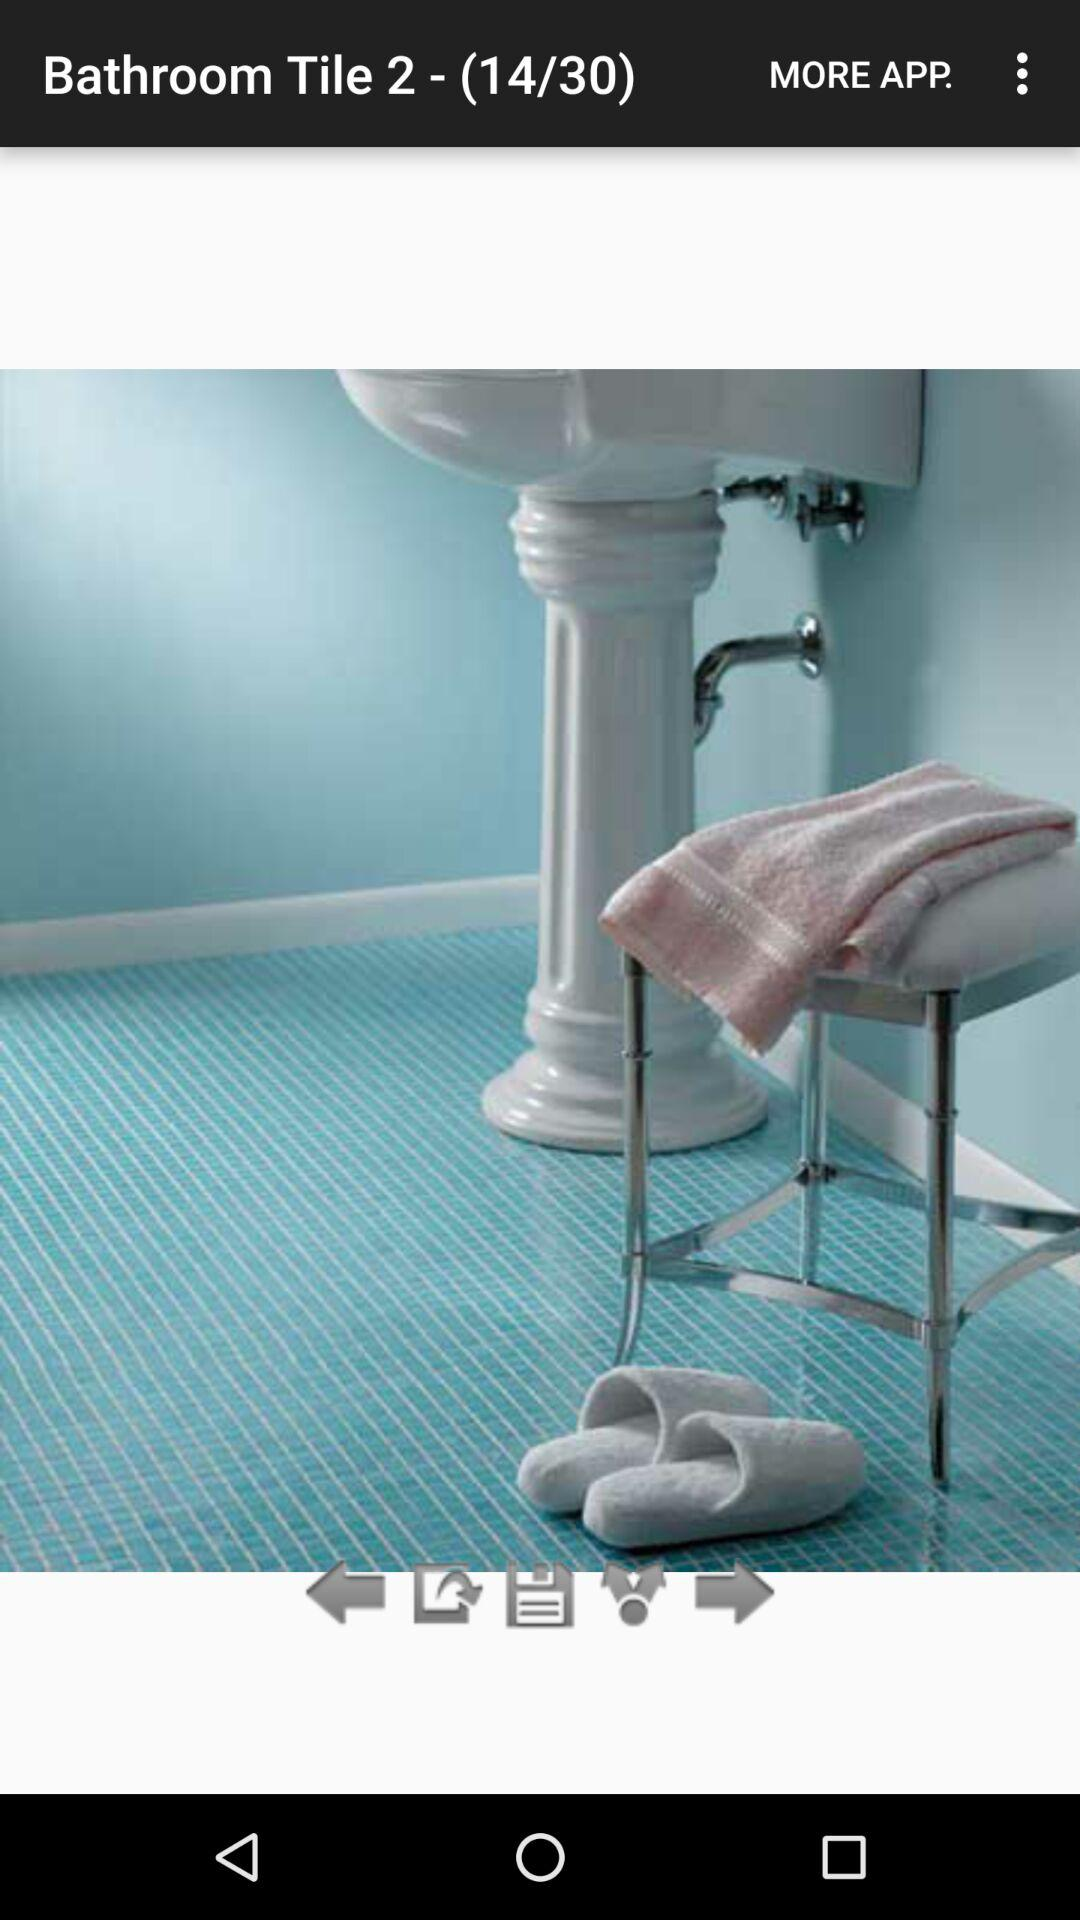Which slide are we on? You are on the 14th slide. 